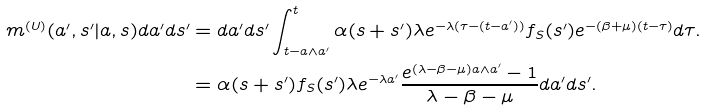Convert formula to latex. <formula><loc_0><loc_0><loc_500><loc_500>m ^ { ( U ) } ( a ^ { \prime } , s ^ { \prime } | a , s ) d a ^ { \prime } d s ^ { \prime } & = d a ^ { \prime } d s ^ { \prime } \int _ { t - a \wedge a ^ { \prime } } ^ { t } \alpha ( s + s ^ { \prime } ) \lambda e ^ { - \lambda ( \tau - ( t - a ^ { \prime } ) ) } f _ { S } ( s ^ { \prime } ) e ^ { - ( \beta + \mu ) ( t - \tau ) } d \tau . \\ & = \alpha ( s + s ^ { \prime } ) f _ { S } ( s ^ { \prime } ) \lambda e ^ { - \lambda a ^ { \prime } } \frac { e ^ { ( \lambda - \beta - \mu ) a \wedge a ^ { \prime } } - 1 } { \lambda - \beta - \mu } d a ^ { \prime } d s ^ { \prime } .</formula> 